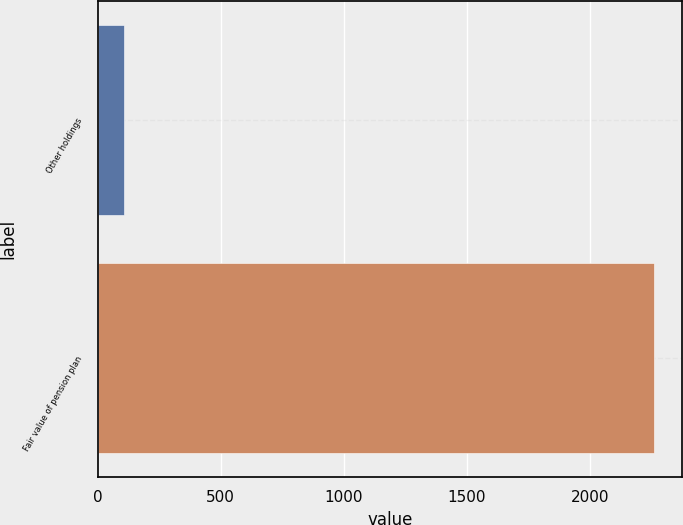Convert chart. <chart><loc_0><loc_0><loc_500><loc_500><bar_chart><fcel>Other holdings<fcel>Fair value of pension plan<nl><fcel>108<fcel>2261<nl></chart> 